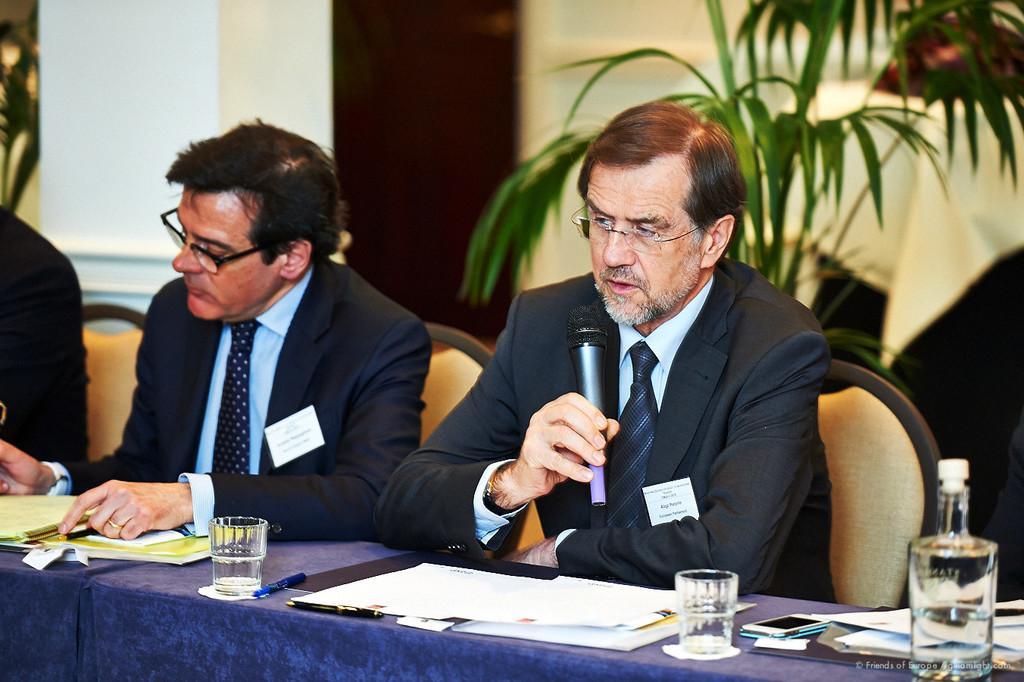Can you describe this image briefly? In this image we can see a man holding the mike and sitting. We can also see two persons sitting on the chairs in front of the table and on the table we can see the glasses, mobile phone, pens and also the papers. In the background we can see the house plant and also the wall. 